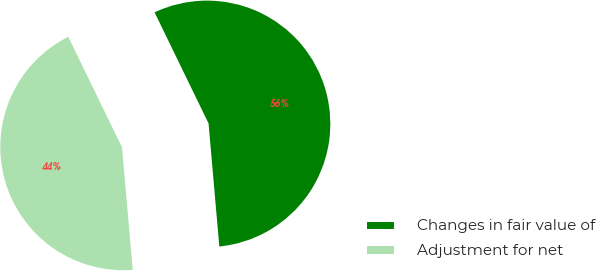Convert chart. <chart><loc_0><loc_0><loc_500><loc_500><pie_chart><fcel>Changes in fair value of<fcel>Adjustment for net<nl><fcel>55.81%<fcel>44.19%<nl></chart> 